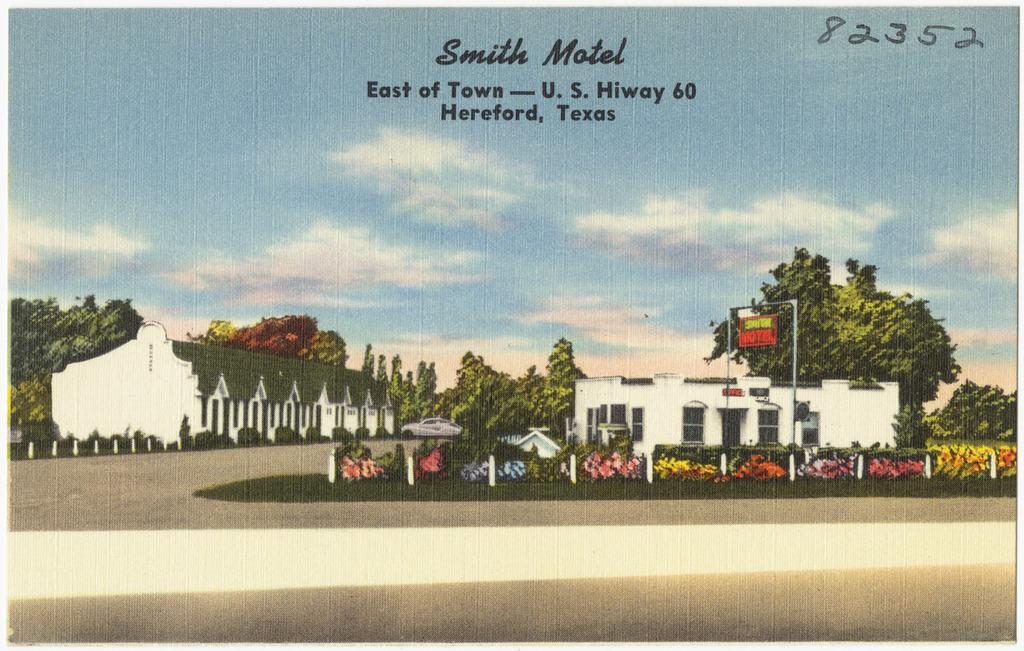Can you describe this image briefly? In this picture we can see road,plants,board and houses. In the background we can see trees,car and sky. At the top we can see text. 